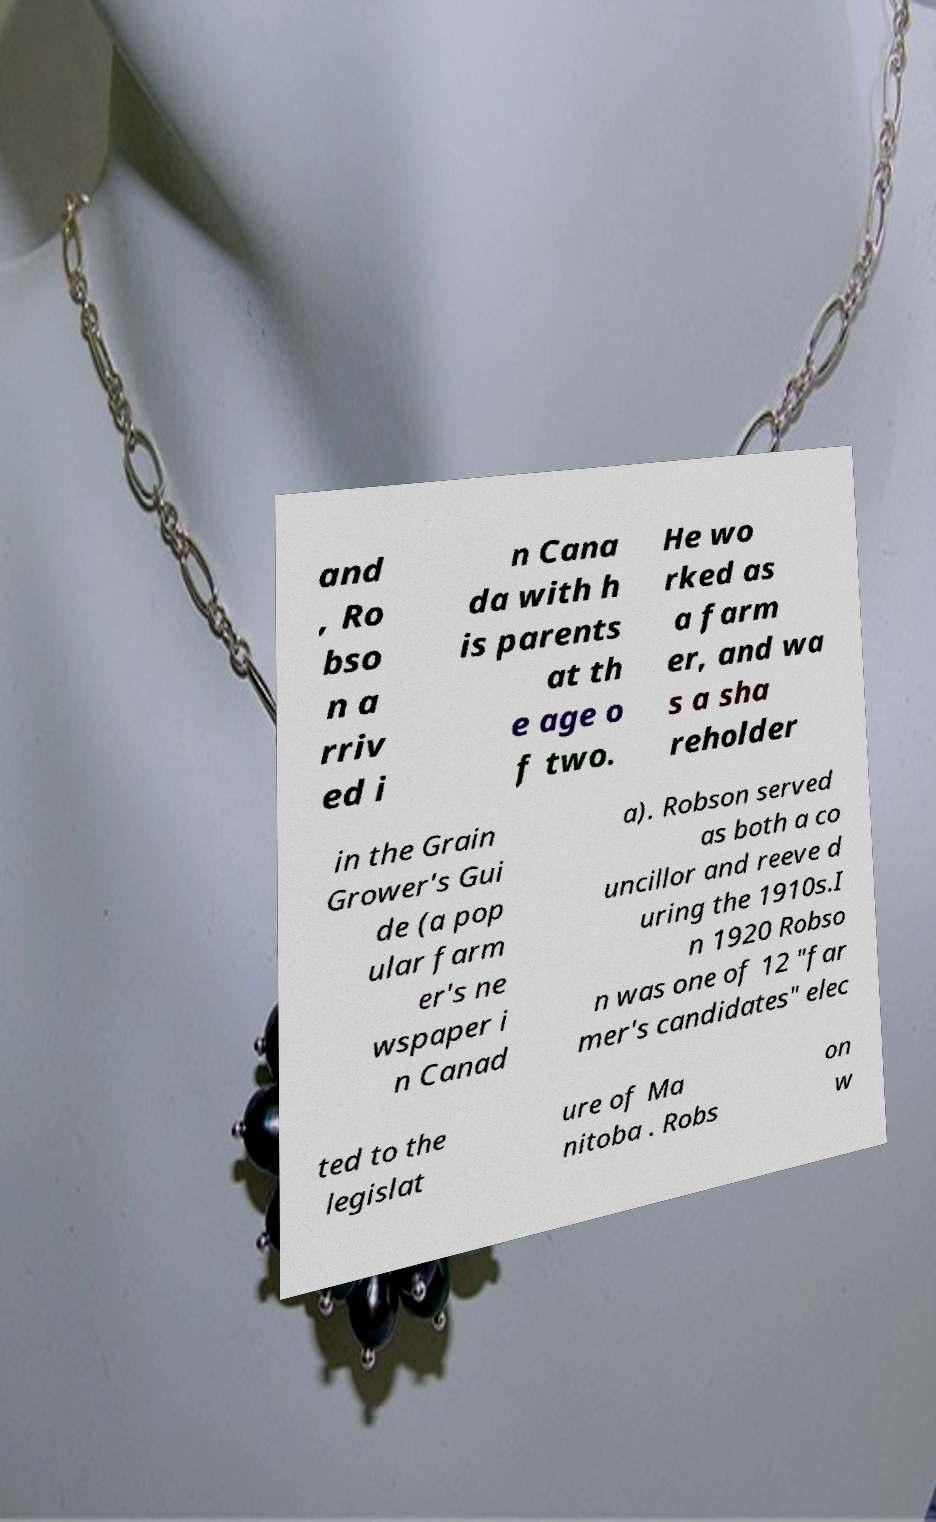Can you accurately transcribe the text from the provided image for me? and , Ro bso n a rriv ed i n Cana da with h is parents at th e age o f two. He wo rked as a farm er, and wa s a sha reholder in the Grain Grower's Gui de (a pop ular farm er's ne wspaper i n Canad a). Robson served as both a co uncillor and reeve d uring the 1910s.I n 1920 Robso n was one of 12 "far mer's candidates" elec ted to the legislat ure of Ma nitoba . Robs on w 